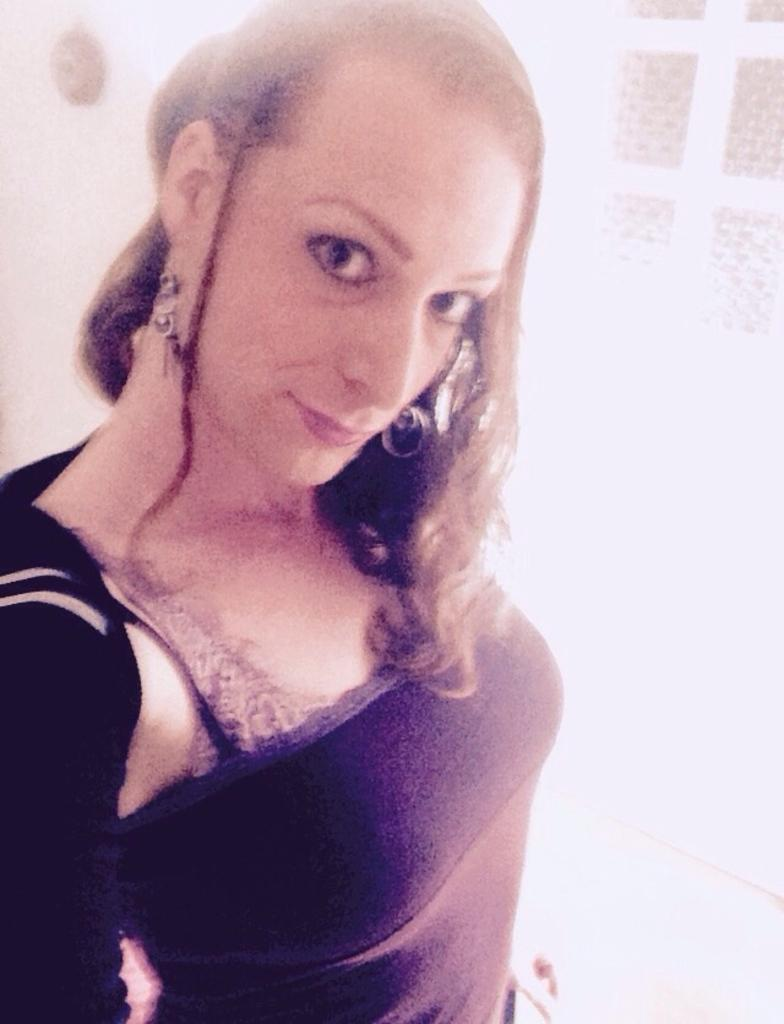What is the main subject of the image? The main subject of the image is a picture of a woman. What color is the background of the image? The background of the image is white. What type of scent can be detected from the woman in the image? There is no information about the scent of the woman in the image, as it is a visual medium. 